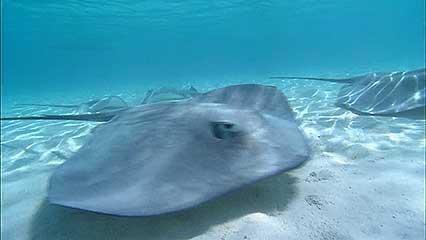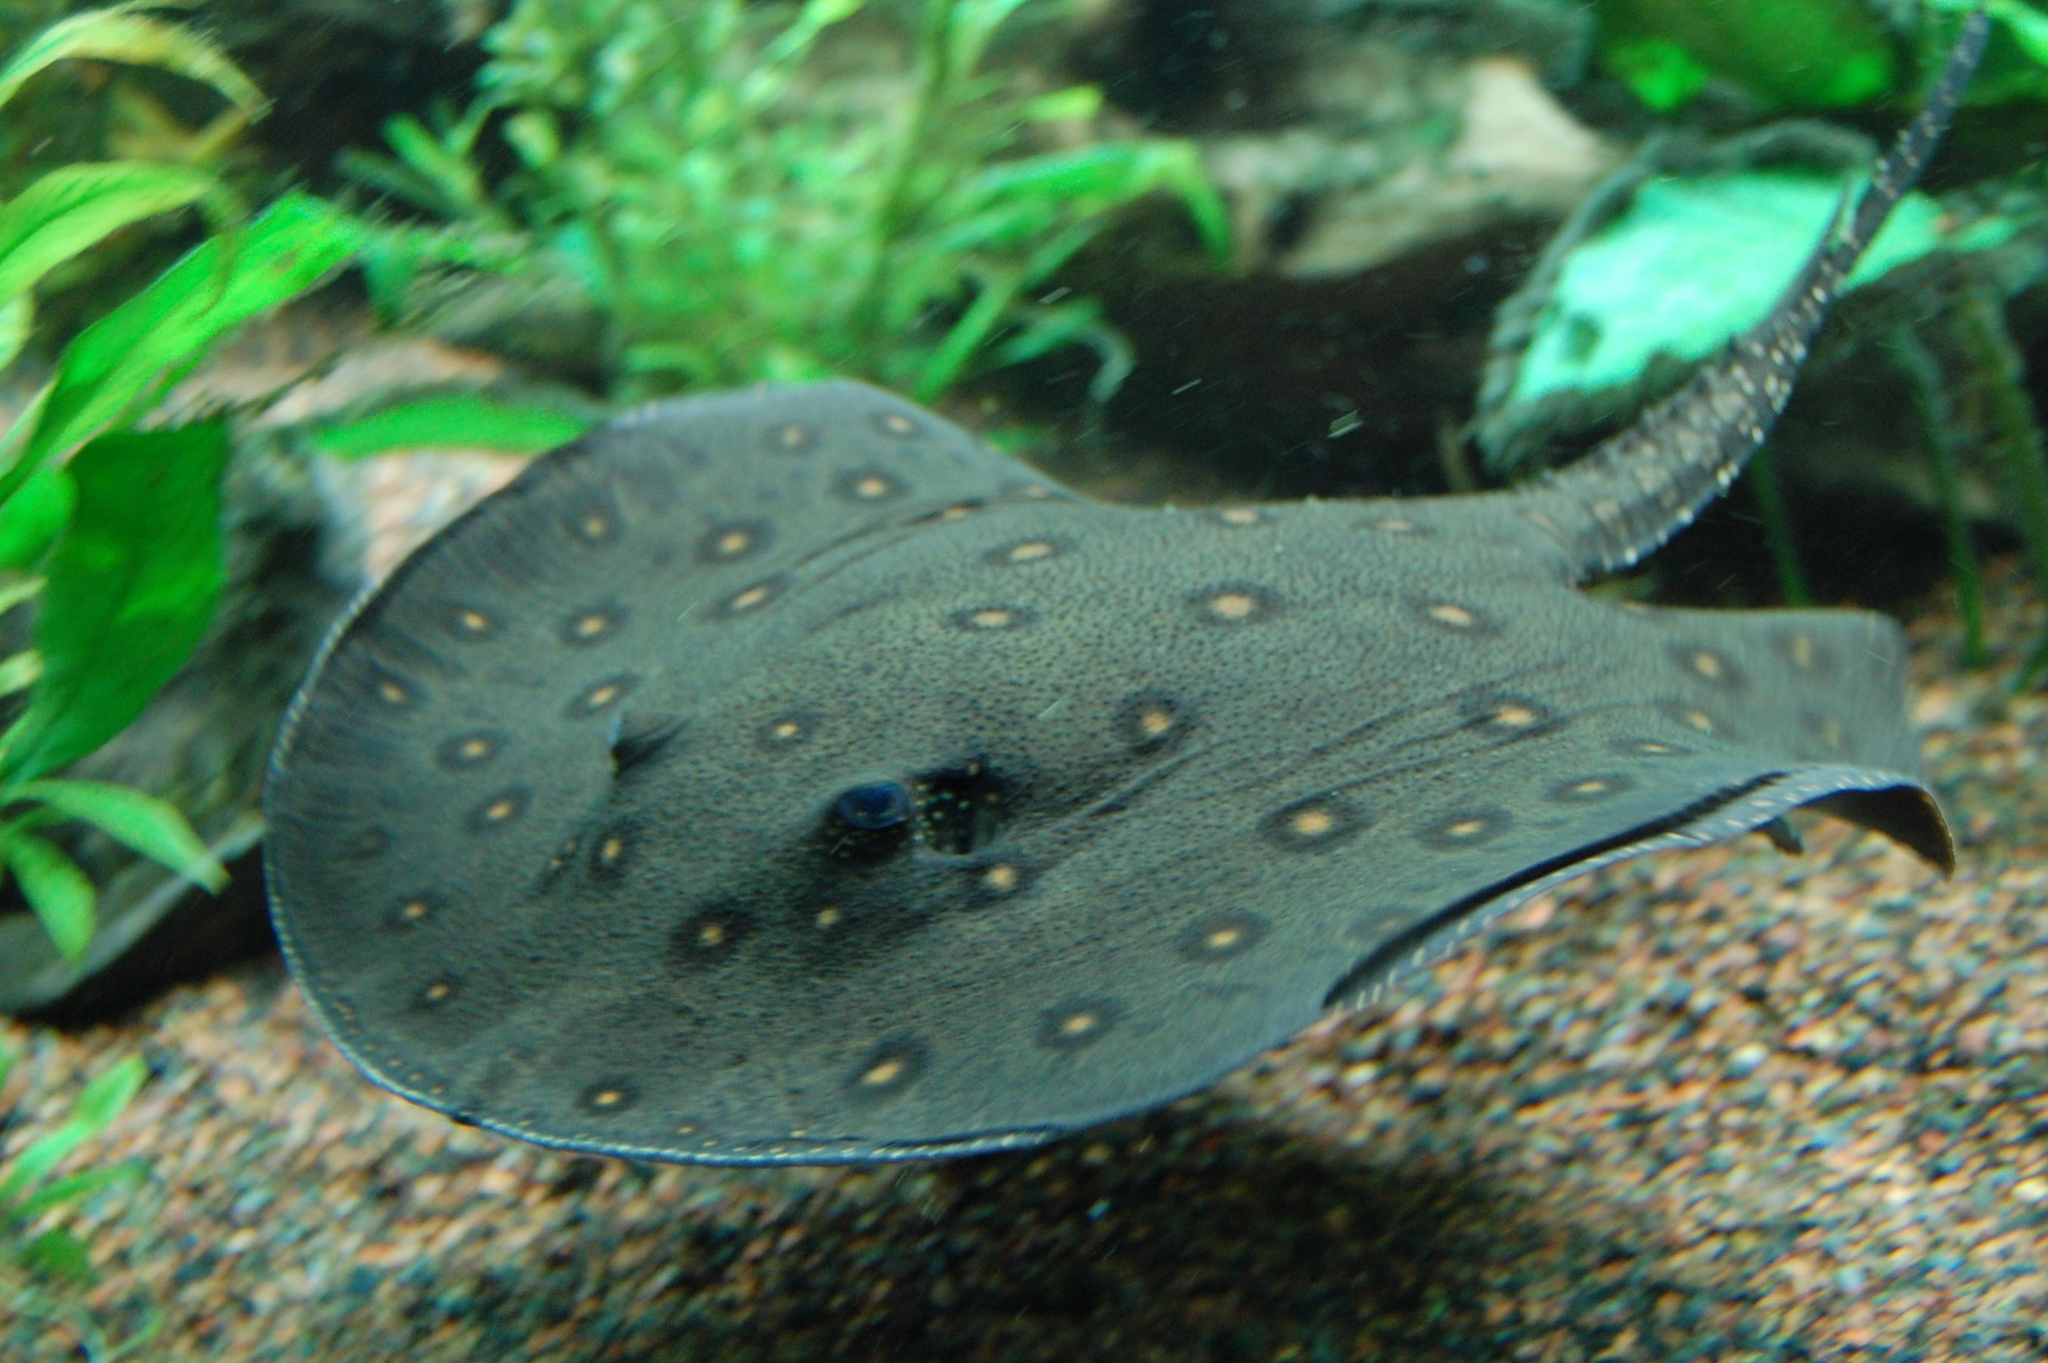The first image is the image on the left, the second image is the image on the right. Given the left and right images, does the statement "Two stingray are present in the right image." hold true? Answer yes or no. No. 